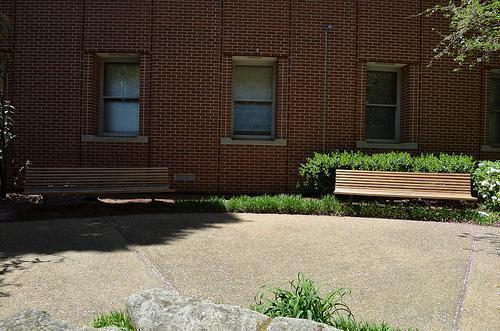How many benches are there?
Give a very brief answer. 2. 